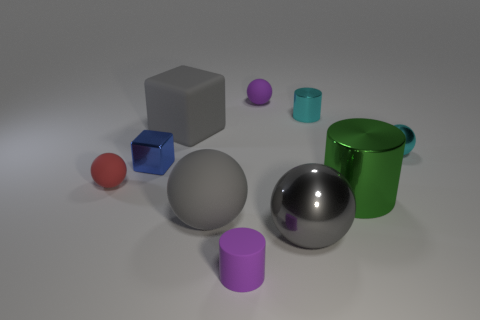Do the metal cube and the gray shiny thing have the same size?
Provide a succinct answer. No. There is a ball that is behind the cylinder that is behind the big shiny cylinder; are there any purple cylinders that are on the right side of it?
Keep it short and to the point. No. There is a tiny cyan object that is the same shape as the large green thing; what material is it?
Your answer should be very brief. Metal. What color is the small cylinder on the left side of the purple sphere?
Ensure brevity in your answer.  Purple. How big is the cyan shiny sphere?
Give a very brief answer. Small. Do the cyan sphere and the gray rubber object that is in front of the tiny blue cube have the same size?
Keep it short and to the point. No. What color is the large metal thing behind the large gray object on the right side of the tiny cylinder that is in front of the cyan sphere?
Keep it short and to the point. Green. Is the material of the tiny cylinder that is behind the blue object the same as the small purple ball?
Offer a very short reply. No. How many other objects are there of the same material as the tiny purple ball?
Your answer should be compact. 4. What material is the green cylinder that is the same size as the gray block?
Make the answer very short. Metal. 